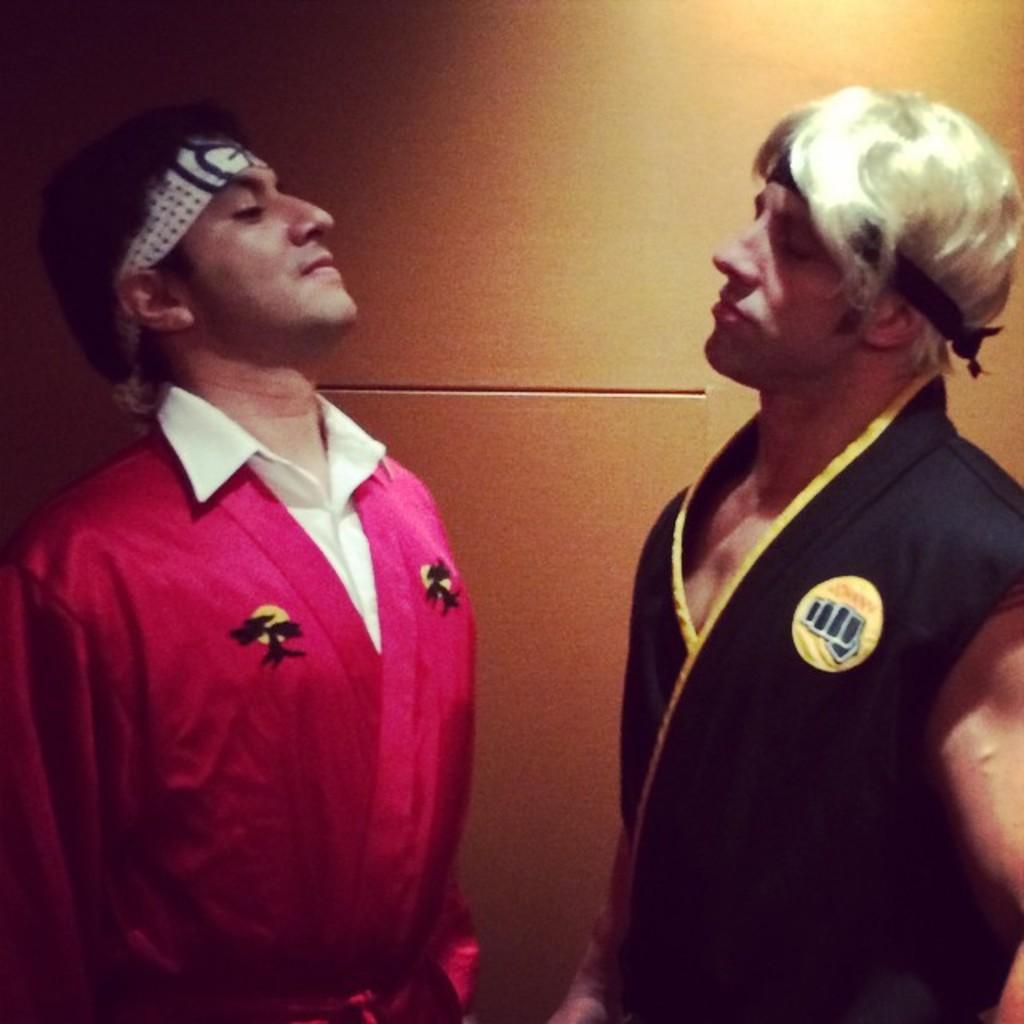Please provide a concise description of this image. In this picture we can see two persons standing. In the background it is well. 